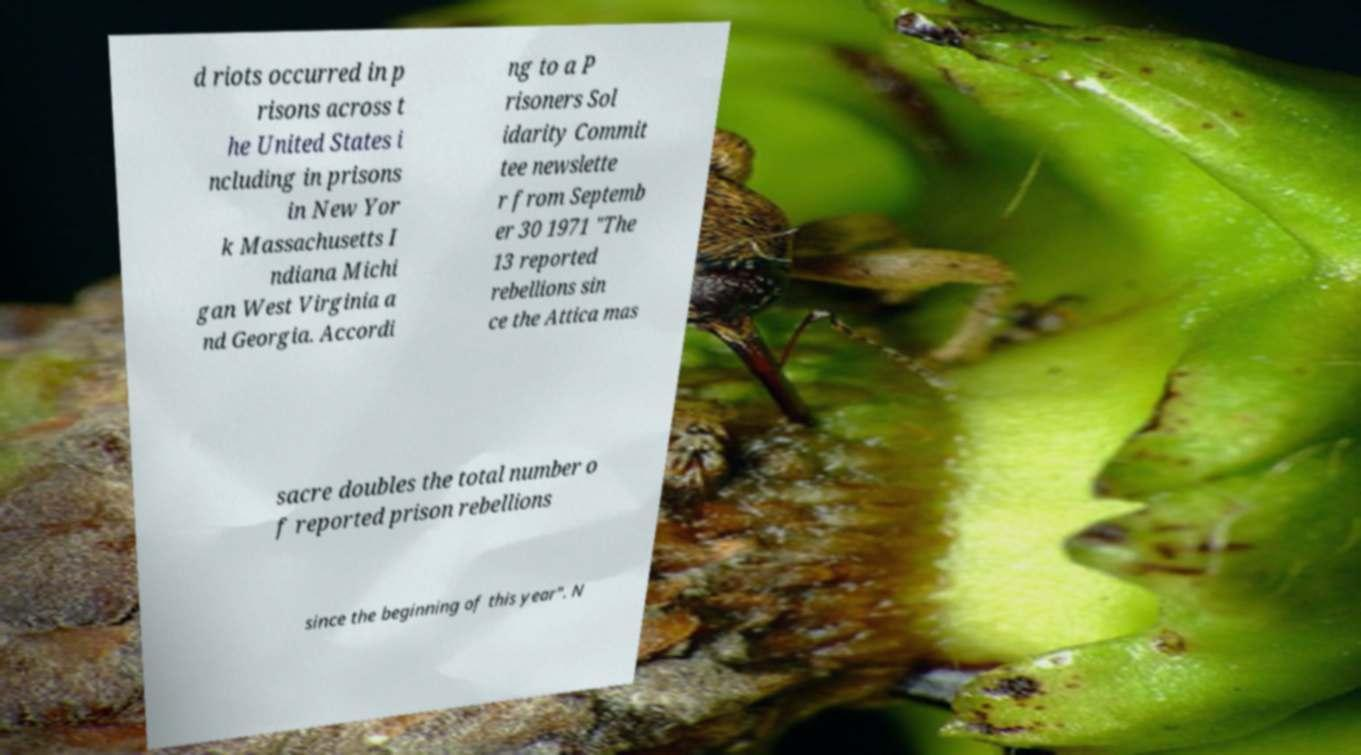I need the written content from this picture converted into text. Can you do that? d riots occurred in p risons across t he United States i ncluding in prisons in New Yor k Massachusetts I ndiana Michi gan West Virginia a nd Georgia. Accordi ng to a P risoners Sol idarity Commit tee newslette r from Septemb er 30 1971 "The 13 reported rebellions sin ce the Attica mas sacre doubles the total number o f reported prison rebellions since the beginning of this year". N 